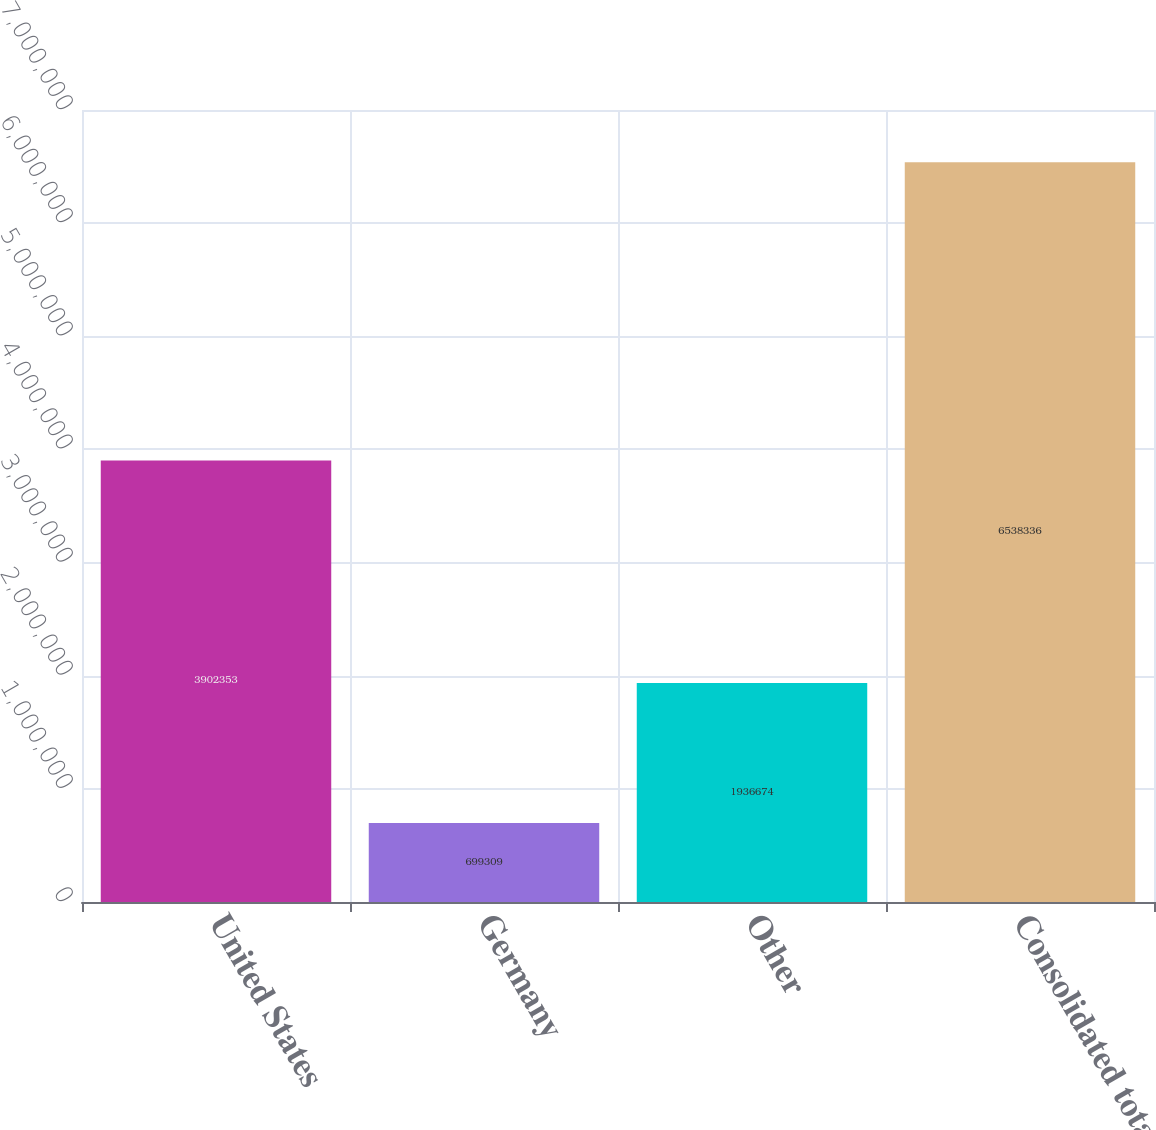Convert chart. <chart><loc_0><loc_0><loc_500><loc_500><bar_chart><fcel>United States<fcel>Germany<fcel>Other<fcel>Consolidated total<nl><fcel>3.90235e+06<fcel>699309<fcel>1.93667e+06<fcel>6.53834e+06<nl></chart> 